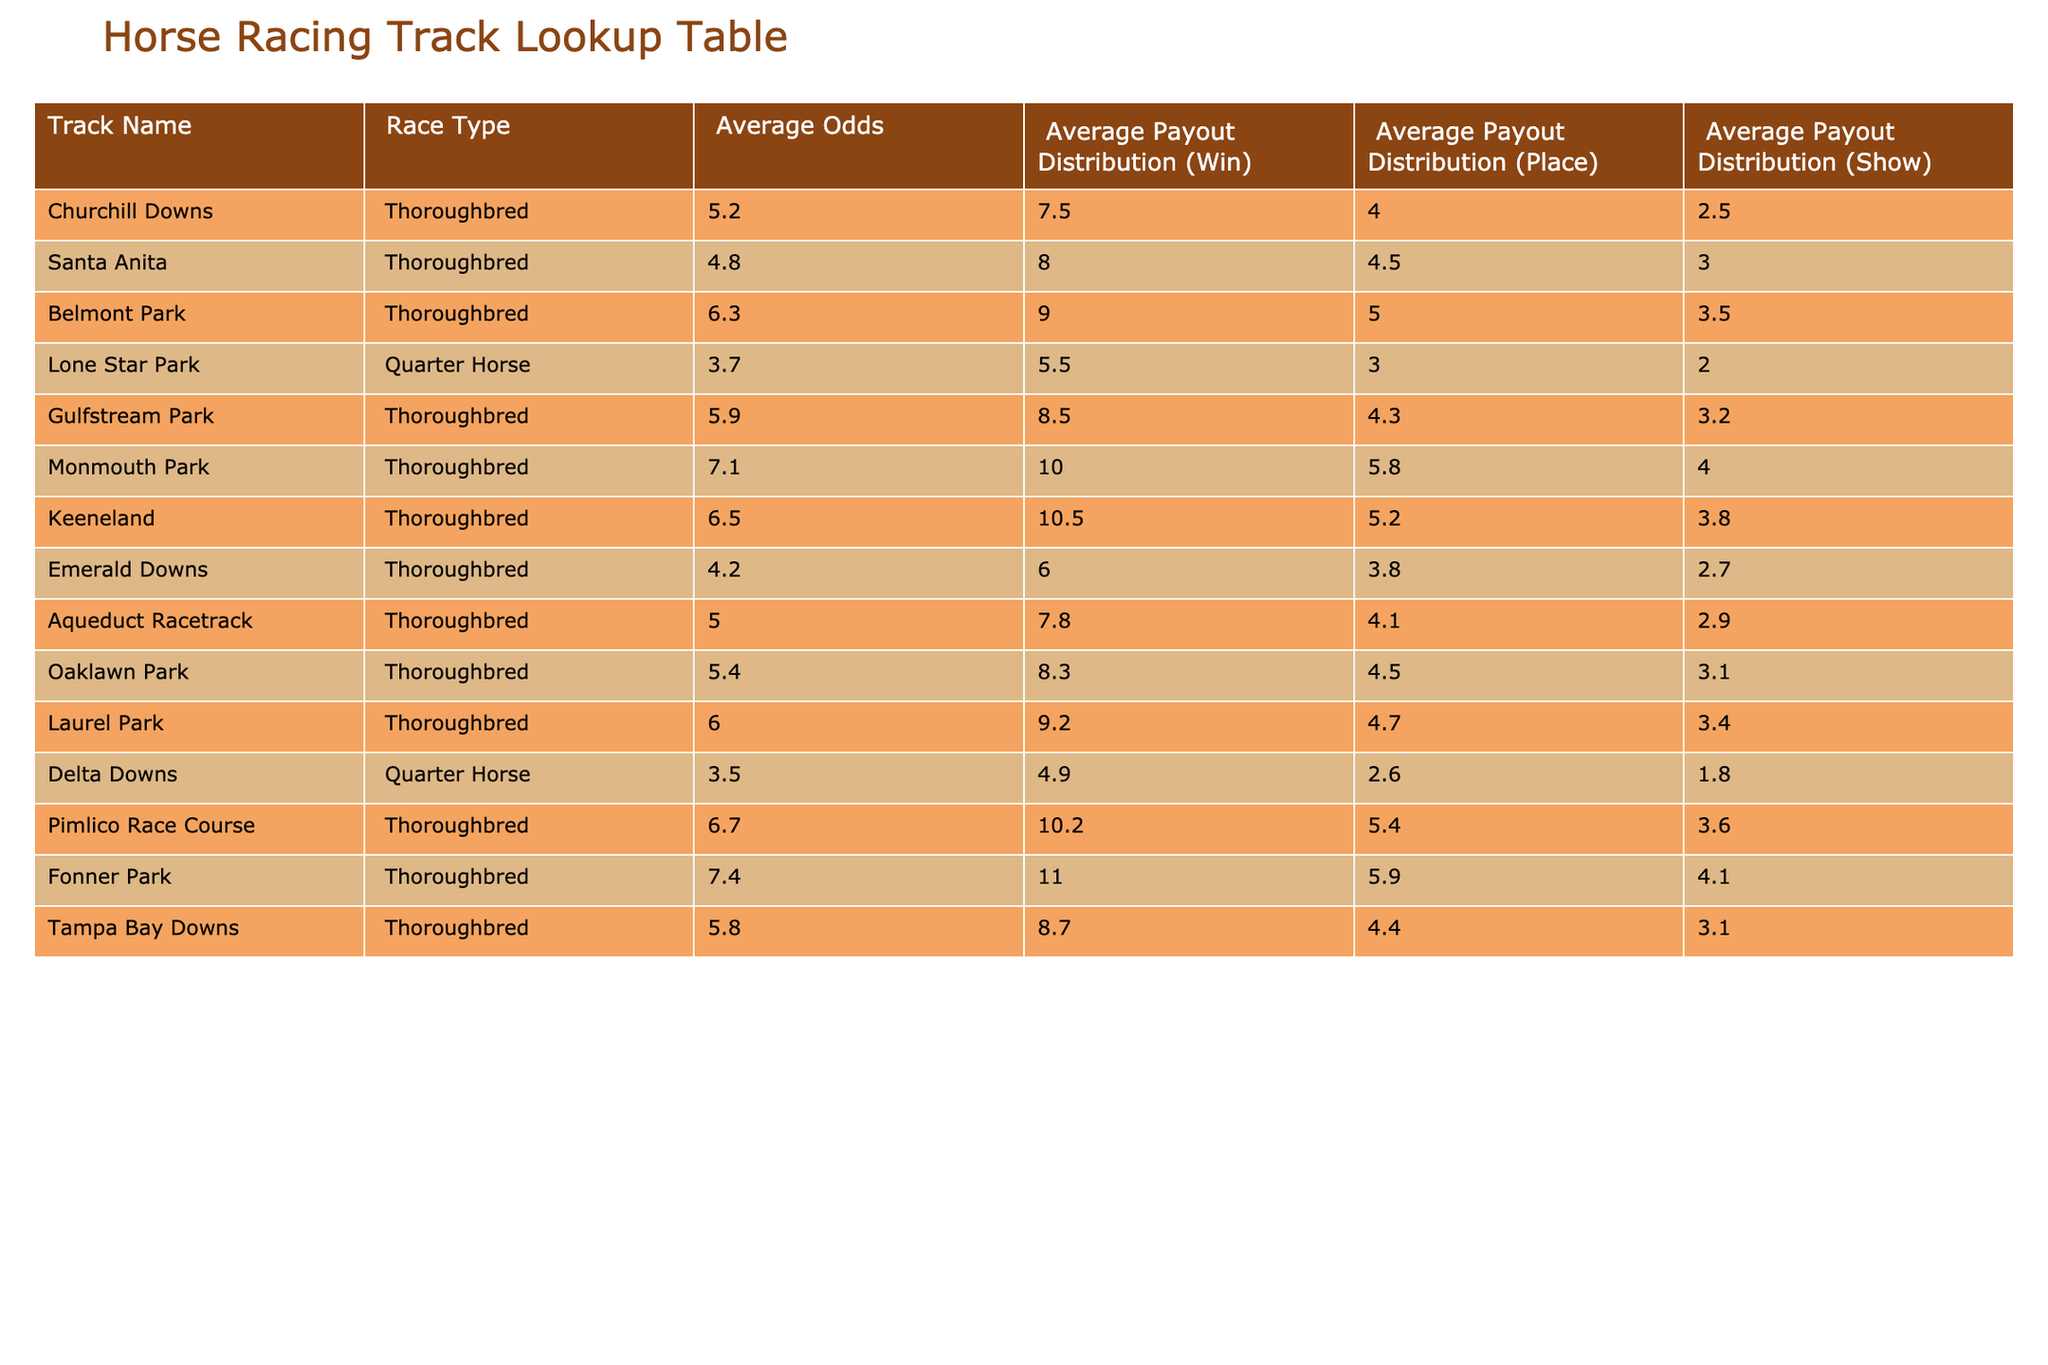What are the average odds for Belmont Park? From the table, we can look up the row for Belmont Park and find the "Average Odds" column, which directly shows the value.
Answer: 6.3 Which track has the highest average payout distribution for winning? By scanning the "Average Payout Distribution (Win)" column, we can identify the maximum value. The maximum payout is 11.0 at Fonner Park.
Answer: 11.0 What is the average odds for Thoroughbred races compared to Quarter Horse races? To find the average odds for Thoroughbred, we sum the average odds for all Thoroughbred tracks and divide by the number of such tracks (8): (5.2 + 4.8 + 6.3 + 5.9 + 7.1 + 6.5 + 4.2 + 5.0 + 5.4 + 6.0 + 6.7 + 7.4 + 5.8) / 13 = 6.16. For Quarter Horse, we have two tracks: Lone Star Park and Delta Downs, yielding (3.7 + 3.5) / 2 = 3.6. Therefore, Thoroughbred races have higher average odds.
Answer: Thoroughbreds are 6.16, Quarter Horses are 3.6 Is the average payout distribution for place at Santa Anita greater than that at Gulfstream Park? Looking at the "Average Payout Distribution (Place)" column, Santa Anita has a value of 4.5 and Gulfstream Park has a value of 4.3. Since 4.5 is greater than 4.3, the statement is true.
Answer: Yes Which track has the lowest average odds and how do those odds compare to average odds of Churchill Downs? The lowest average odds in the table are found at Lone Star Park: 3.7. Comparing this to Churchill Downs at 5.2, we see that Lone Star Park’s odds are 1.5 lower than Churchill Downs’.
Answer: Lone Star Park, 3.7 vs. Churchill Downs, 5.2 What is the total average payout distribution for show across all tracks? To find the total average payout distribution for show, we will add the “Average Payout Distribution (Show)” for all tracks: (2.5 + 3.0 + 3.5 + 2.0 + 3.2 + 4.0 + 3.8 + 2.7 + 2.9 + 3.4 + 1.8 + 3.6 + 4.1) = 39.6. Then divide this total by the number of tracks (13): 39.6 / 13 = 3.05.
Answer: 3.05 Is there a track where the average payout distribution (win) is less than 5? Upon reviewing the "Average Payout Distribution (Win)" column, we see that Lone Star Park (5.5) and Delta Downs (4.9) are less than 5. The statement is therefore true for Delta Downs.
Answer: Yes What track has the most balanced average payout distributions across win, place, and show? To evaluate balance, we can look for the smallest difference between win, place, and show payouts. Upon reviewing the respective payouts: Monmouth Park (10.0, 5.8, 4.0) shows more balance with a minimal spread.
Answer: Monmouth Park 